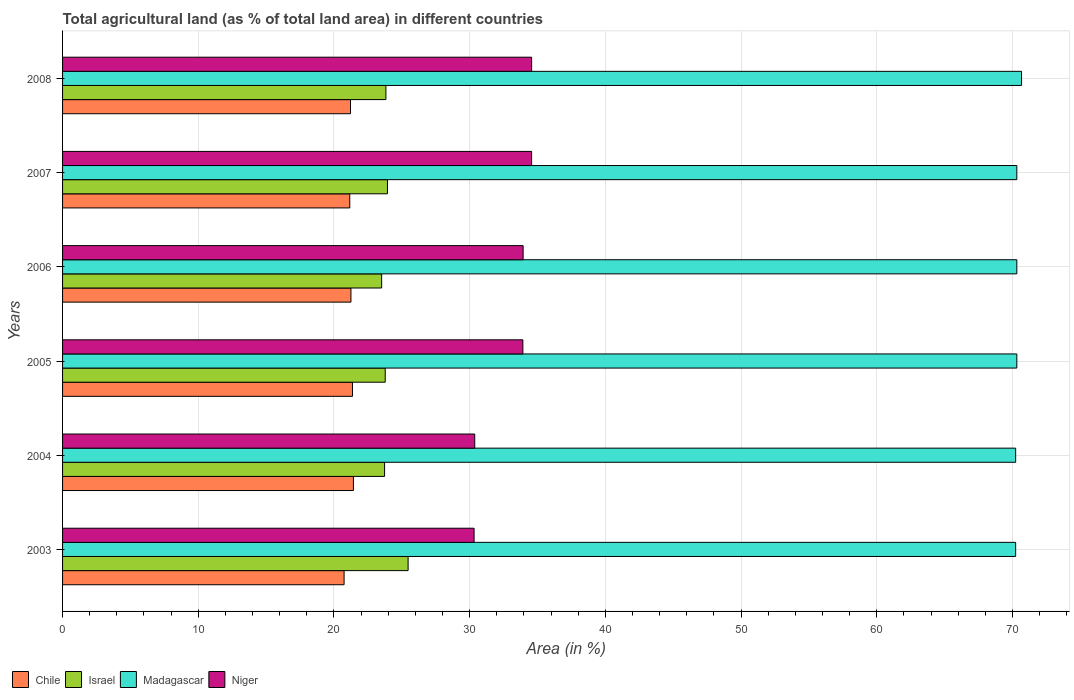How many different coloured bars are there?
Make the answer very short. 4. How many groups of bars are there?
Keep it short and to the point. 6. Are the number of bars per tick equal to the number of legend labels?
Your response must be concise. Yes. How many bars are there on the 6th tick from the bottom?
Give a very brief answer. 4. What is the percentage of agricultural land in Madagascar in 2003?
Keep it short and to the point. 70.23. Across all years, what is the maximum percentage of agricultural land in Niger?
Ensure brevity in your answer.  34.56. Across all years, what is the minimum percentage of agricultural land in Madagascar?
Provide a succinct answer. 70.23. In which year was the percentage of agricultural land in Niger maximum?
Keep it short and to the point. 2007. In which year was the percentage of agricultural land in Niger minimum?
Your response must be concise. 2003. What is the total percentage of agricultural land in Chile in the graph?
Give a very brief answer. 127.17. What is the difference between the percentage of agricultural land in Madagascar in 2003 and that in 2007?
Your response must be concise. -0.09. What is the difference between the percentage of agricultural land in Chile in 2005 and the percentage of agricultural land in Israel in 2007?
Your answer should be very brief. -2.58. What is the average percentage of agricultural land in Israel per year?
Ensure brevity in your answer.  24.04. In the year 2004, what is the difference between the percentage of agricultural land in Chile and percentage of agricultural land in Israel?
Offer a terse response. -2.3. What is the ratio of the percentage of agricultural land in Niger in 2006 to that in 2007?
Make the answer very short. 0.98. Is the percentage of agricultural land in Madagascar in 2005 less than that in 2007?
Make the answer very short. No. What is the difference between the highest and the second highest percentage of agricultural land in Israel?
Make the answer very short. 1.52. What is the difference between the highest and the lowest percentage of agricultural land in Madagascar?
Your response must be concise. 0.43. What does the 2nd bar from the top in 2007 represents?
Your response must be concise. Madagascar. What does the 3rd bar from the bottom in 2004 represents?
Provide a succinct answer. Madagascar. Is it the case that in every year, the sum of the percentage of agricultural land in Chile and percentage of agricultural land in Niger is greater than the percentage of agricultural land in Madagascar?
Your answer should be very brief. No. Are all the bars in the graph horizontal?
Provide a short and direct response. Yes. How many years are there in the graph?
Offer a very short reply. 6. Does the graph contain any zero values?
Your response must be concise. No. How many legend labels are there?
Keep it short and to the point. 4. What is the title of the graph?
Offer a very short reply. Total agricultural land (as % of total land area) in different countries. Does "Suriname" appear as one of the legend labels in the graph?
Ensure brevity in your answer.  No. What is the label or title of the X-axis?
Ensure brevity in your answer.  Area (in %). What is the label or title of the Y-axis?
Offer a terse response. Years. What is the Area (in %) in Chile in 2003?
Your response must be concise. 20.75. What is the Area (in %) of Israel in 2003?
Give a very brief answer. 25.46. What is the Area (in %) of Madagascar in 2003?
Keep it short and to the point. 70.23. What is the Area (in %) of Niger in 2003?
Your answer should be compact. 30.32. What is the Area (in %) in Chile in 2004?
Your answer should be compact. 21.43. What is the Area (in %) of Israel in 2004?
Ensure brevity in your answer.  23.73. What is the Area (in %) of Madagascar in 2004?
Provide a short and direct response. 70.23. What is the Area (in %) of Niger in 2004?
Ensure brevity in your answer.  30.37. What is the Area (in %) of Chile in 2005?
Your answer should be compact. 21.36. What is the Area (in %) in Israel in 2005?
Offer a very short reply. 23.78. What is the Area (in %) in Madagascar in 2005?
Offer a terse response. 70.32. What is the Area (in %) in Niger in 2005?
Keep it short and to the point. 33.92. What is the Area (in %) in Chile in 2006?
Keep it short and to the point. 21.25. What is the Area (in %) of Israel in 2006?
Make the answer very short. 23.51. What is the Area (in %) in Madagascar in 2006?
Your answer should be compact. 70.32. What is the Area (in %) in Niger in 2006?
Make the answer very short. 33.94. What is the Area (in %) of Chile in 2007?
Provide a short and direct response. 21.16. What is the Area (in %) in Israel in 2007?
Give a very brief answer. 23.94. What is the Area (in %) in Madagascar in 2007?
Give a very brief answer. 70.32. What is the Area (in %) of Niger in 2007?
Your response must be concise. 34.56. What is the Area (in %) in Chile in 2008?
Your answer should be very brief. 21.22. What is the Area (in %) of Israel in 2008?
Make the answer very short. 23.83. What is the Area (in %) in Madagascar in 2008?
Give a very brief answer. 70.67. What is the Area (in %) of Niger in 2008?
Your answer should be compact. 34.56. Across all years, what is the maximum Area (in %) in Chile?
Offer a terse response. 21.43. Across all years, what is the maximum Area (in %) of Israel?
Keep it short and to the point. 25.46. Across all years, what is the maximum Area (in %) of Madagascar?
Ensure brevity in your answer.  70.67. Across all years, what is the maximum Area (in %) in Niger?
Your answer should be very brief. 34.56. Across all years, what is the minimum Area (in %) of Chile?
Give a very brief answer. 20.75. Across all years, what is the minimum Area (in %) of Israel?
Provide a succinct answer. 23.51. Across all years, what is the minimum Area (in %) in Madagascar?
Offer a terse response. 70.23. Across all years, what is the minimum Area (in %) in Niger?
Keep it short and to the point. 30.32. What is the total Area (in %) of Chile in the graph?
Provide a succinct answer. 127.17. What is the total Area (in %) in Israel in the graph?
Offer a terse response. 144.25. What is the total Area (in %) of Madagascar in the graph?
Make the answer very short. 422.09. What is the total Area (in %) of Niger in the graph?
Give a very brief answer. 197.68. What is the difference between the Area (in %) of Chile in 2003 and that in 2004?
Your answer should be compact. -0.69. What is the difference between the Area (in %) in Israel in 2003 and that in 2004?
Offer a terse response. 1.73. What is the difference between the Area (in %) of Madagascar in 2003 and that in 2004?
Your answer should be compact. 0. What is the difference between the Area (in %) of Niger in 2003 and that in 2004?
Your answer should be compact. -0.05. What is the difference between the Area (in %) in Chile in 2003 and that in 2005?
Your answer should be very brief. -0.62. What is the difference between the Area (in %) of Israel in 2003 and that in 2005?
Make the answer very short. 1.69. What is the difference between the Area (in %) of Madagascar in 2003 and that in 2005?
Your response must be concise. -0.09. What is the difference between the Area (in %) in Niger in 2003 and that in 2005?
Make the answer very short. -3.59. What is the difference between the Area (in %) of Chile in 2003 and that in 2006?
Offer a terse response. -0.5. What is the difference between the Area (in %) in Israel in 2003 and that in 2006?
Keep it short and to the point. 1.95. What is the difference between the Area (in %) of Madagascar in 2003 and that in 2006?
Provide a succinct answer. -0.09. What is the difference between the Area (in %) of Niger in 2003 and that in 2006?
Provide a short and direct response. -3.61. What is the difference between the Area (in %) in Chile in 2003 and that in 2007?
Your answer should be very brief. -0.42. What is the difference between the Area (in %) of Israel in 2003 and that in 2007?
Offer a terse response. 1.52. What is the difference between the Area (in %) in Madagascar in 2003 and that in 2007?
Give a very brief answer. -0.09. What is the difference between the Area (in %) in Niger in 2003 and that in 2007?
Your answer should be very brief. -4.24. What is the difference between the Area (in %) of Chile in 2003 and that in 2008?
Keep it short and to the point. -0.47. What is the difference between the Area (in %) in Israel in 2003 and that in 2008?
Ensure brevity in your answer.  1.64. What is the difference between the Area (in %) in Madagascar in 2003 and that in 2008?
Your answer should be very brief. -0.43. What is the difference between the Area (in %) of Niger in 2003 and that in 2008?
Give a very brief answer. -4.24. What is the difference between the Area (in %) in Chile in 2004 and that in 2005?
Your answer should be very brief. 0.07. What is the difference between the Area (in %) of Israel in 2004 and that in 2005?
Provide a succinct answer. -0.05. What is the difference between the Area (in %) of Madagascar in 2004 and that in 2005?
Ensure brevity in your answer.  -0.09. What is the difference between the Area (in %) in Niger in 2004 and that in 2005?
Offer a terse response. -3.55. What is the difference between the Area (in %) in Chile in 2004 and that in 2006?
Ensure brevity in your answer.  0.18. What is the difference between the Area (in %) in Israel in 2004 and that in 2006?
Offer a very short reply. 0.22. What is the difference between the Area (in %) in Madagascar in 2004 and that in 2006?
Offer a terse response. -0.09. What is the difference between the Area (in %) in Niger in 2004 and that in 2006?
Make the answer very short. -3.57. What is the difference between the Area (in %) of Chile in 2004 and that in 2007?
Your response must be concise. 0.27. What is the difference between the Area (in %) in Israel in 2004 and that in 2007?
Your answer should be very brief. -0.21. What is the difference between the Area (in %) in Madagascar in 2004 and that in 2007?
Ensure brevity in your answer.  -0.09. What is the difference between the Area (in %) of Niger in 2004 and that in 2007?
Your response must be concise. -4.19. What is the difference between the Area (in %) of Chile in 2004 and that in 2008?
Your answer should be compact. 0.21. What is the difference between the Area (in %) of Israel in 2004 and that in 2008?
Your answer should be very brief. -0.1. What is the difference between the Area (in %) in Madagascar in 2004 and that in 2008?
Keep it short and to the point. -0.43. What is the difference between the Area (in %) of Niger in 2004 and that in 2008?
Make the answer very short. -4.19. What is the difference between the Area (in %) of Chile in 2005 and that in 2006?
Your response must be concise. 0.11. What is the difference between the Area (in %) in Israel in 2005 and that in 2006?
Offer a terse response. 0.26. What is the difference between the Area (in %) in Madagascar in 2005 and that in 2006?
Ensure brevity in your answer.  0. What is the difference between the Area (in %) in Niger in 2005 and that in 2006?
Give a very brief answer. -0.02. What is the difference between the Area (in %) in Chile in 2005 and that in 2007?
Make the answer very short. 0.2. What is the difference between the Area (in %) of Israel in 2005 and that in 2007?
Ensure brevity in your answer.  -0.17. What is the difference between the Area (in %) of Niger in 2005 and that in 2007?
Provide a short and direct response. -0.65. What is the difference between the Area (in %) of Chile in 2005 and that in 2008?
Keep it short and to the point. 0.15. What is the difference between the Area (in %) of Israel in 2005 and that in 2008?
Offer a terse response. -0.05. What is the difference between the Area (in %) of Madagascar in 2005 and that in 2008?
Offer a very short reply. -0.35. What is the difference between the Area (in %) in Niger in 2005 and that in 2008?
Offer a terse response. -0.65. What is the difference between the Area (in %) in Chile in 2006 and that in 2007?
Your answer should be very brief. 0.09. What is the difference between the Area (in %) of Israel in 2006 and that in 2007?
Provide a succinct answer. -0.43. What is the difference between the Area (in %) of Madagascar in 2006 and that in 2007?
Your response must be concise. 0. What is the difference between the Area (in %) in Niger in 2006 and that in 2007?
Give a very brief answer. -0.63. What is the difference between the Area (in %) in Chile in 2006 and that in 2008?
Provide a short and direct response. 0.03. What is the difference between the Area (in %) of Israel in 2006 and that in 2008?
Make the answer very short. -0.31. What is the difference between the Area (in %) of Madagascar in 2006 and that in 2008?
Offer a very short reply. -0.35. What is the difference between the Area (in %) of Niger in 2006 and that in 2008?
Your response must be concise. -0.63. What is the difference between the Area (in %) in Chile in 2007 and that in 2008?
Offer a very short reply. -0.05. What is the difference between the Area (in %) in Israel in 2007 and that in 2008?
Your answer should be compact. 0.12. What is the difference between the Area (in %) of Madagascar in 2007 and that in 2008?
Make the answer very short. -0.35. What is the difference between the Area (in %) in Chile in 2003 and the Area (in %) in Israel in 2004?
Provide a short and direct response. -2.98. What is the difference between the Area (in %) of Chile in 2003 and the Area (in %) of Madagascar in 2004?
Offer a very short reply. -49.49. What is the difference between the Area (in %) in Chile in 2003 and the Area (in %) in Niger in 2004?
Offer a terse response. -9.63. What is the difference between the Area (in %) in Israel in 2003 and the Area (in %) in Madagascar in 2004?
Give a very brief answer. -44.77. What is the difference between the Area (in %) of Israel in 2003 and the Area (in %) of Niger in 2004?
Keep it short and to the point. -4.91. What is the difference between the Area (in %) in Madagascar in 2003 and the Area (in %) in Niger in 2004?
Ensure brevity in your answer.  39.86. What is the difference between the Area (in %) in Chile in 2003 and the Area (in %) in Israel in 2005?
Provide a succinct answer. -3.03. What is the difference between the Area (in %) in Chile in 2003 and the Area (in %) in Madagascar in 2005?
Provide a succinct answer. -49.57. What is the difference between the Area (in %) of Chile in 2003 and the Area (in %) of Niger in 2005?
Ensure brevity in your answer.  -13.17. What is the difference between the Area (in %) in Israel in 2003 and the Area (in %) in Madagascar in 2005?
Give a very brief answer. -44.86. What is the difference between the Area (in %) of Israel in 2003 and the Area (in %) of Niger in 2005?
Make the answer very short. -8.46. What is the difference between the Area (in %) in Madagascar in 2003 and the Area (in %) in Niger in 2005?
Offer a terse response. 36.31. What is the difference between the Area (in %) of Chile in 2003 and the Area (in %) of Israel in 2006?
Make the answer very short. -2.77. What is the difference between the Area (in %) in Chile in 2003 and the Area (in %) in Madagascar in 2006?
Your answer should be very brief. -49.57. What is the difference between the Area (in %) in Chile in 2003 and the Area (in %) in Niger in 2006?
Your answer should be very brief. -13.19. What is the difference between the Area (in %) in Israel in 2003 and the Area (in %) in Madagascar in 2006?
Give a very brief answer. -44.86. What is the difference between the Area (in %) in Israel in 2003 and the Area (in %) in Niger in 2006?
Offer a very short reply. -8.48. What is the difference between the Area (in %) in Madagascar in 2003 and the Area (in %) in Niger in 2006?
Offer a terse response. 36.29. What is the difference between the Area (in %) in Chile in 2003 and the Area (in %) in Israel in 2007?
Provide a succinct answer. -3.2. What is the difference between the Area (in %) in Chile in 2003 and the Area (in %) in Madagascar in 2007?
Keep it short and to the point. -49.57. What is the difference between the Area (in %) of Chile in 2003 and the Area (in %) of Niger in 2007?
Provide a short and direct response. -13.82. What is the difference between the Area (in %) in Israel in 2003 and the Area (in %) in Madagascar in 2007?
Give a very brief answer. -44.86. What is the difference between the Area (in %) in Israel in 2003 and the Area (in %) in Niger in 2007?
Provide a succinct answer. -9.1. What is the difference between the Area (in %) of Madagascar in 2003 and the Area (in %) of Niger in 2007?
Your answer should be compact. 35.67. What is the difference between the Area (in %) in Chile in 2003 and the Area (in %) in Israel in 2008?
Offer a very short reply. -3.08. What is the difference between the Area (in %) in Chile in 2003 and the Area (in %) in Madagascar in 2008?
Offer a terse response. -49.92. What is the difference between the Area (in %) in Chile in 2003 and the Area (in %) in Niger in 2008?
Your response must be concise. -13.82. What is the difference between the Area (in %) in Israel in 2003 and the Area (in %) in Madagascar in 2008?
Offer a terse response. -45.2. What is the difference between the Area (in %) in Israel in 2003 and the Area (in %) in Niger in 2008?
Keep it short and to the point. -9.1. What is the difference between the Area (in %) of Madagascar in 2003 and the Area (in %) of Niger in 2008?
Your answer should be compact. 35.67. What is the difference between the Area (in %) of Chile in 2004 and the Area (in %) of Israel in 2005?
Your answer should be compact. -2.34. What is the difference between the Area (in %) in Chile in 2004 and the Area (in %) in Madagascar in 2005?
Give a very brief answer. -48.89. What is the difference between the Area (in %) in Chile in 2004 and the Area (in %) in Niger in 2005?
Offer a terse response. -12.49. What is the difference between the Area (in %) in Israel in 2004 and the Area (in %) in Madagascar in 2005?
Make the answer very short. -46.59. What is the difference between the Area (in %) of Israel in 2004 and the Area (in %) of Niger in 2005?
Your response must be concise. -10.19. What is the difference between the Area (in %) in Madagascar in 2004 and the Area (in %) in Niger in 2005?
Give a very brief answer. 36.31. What is the difference between the Area (in %) in Chile in 2004 and the Area (in %) in Israel in 2006?
Your answer should be compact. -2.08. What is the difference between the Area (in %) of Chile in 2004 and the Area (in %) of Madagascar in 2006?
Provide a short and direct response. -48.89. What is the difference between the Area (in %) of Chile in 2004 and the Area (in %) of Niger in 2006?
Ensure brevity in your answer.  -12.51. What is the difference between the Area (in %) in Israel in 2004 and the Area (in %) in Madagascar in 2006?
Provide a succinct answer. -46.59. What is the difference between the Area (in %) in Israel in 2004 and the Area (in %) in Niger in 2006?
Make the answer very short. -10.21. What is the difference between the Area (in %) in Madagascar in 2004 and the Area (in %) in Niger in 2006?
Your response must be concise. 36.29. What is the difference between the Area (in %) of Chile in 2004 and the Area (in %) of Israel in 2007?
Provide a succinct answer. -2.51. What is the difference between the Area (in %) of Chile in 2004 and the Area (in %) of Madagascar in 2007?
Your answer should be compact. -48.89. What is the difference between the Area (in %) of Chile in 2004 and the Area (in %) of Niger in 2007?
Provide a succinct answer. -13.13. What is the difference between the Area (in %) in Israel in 2004 and the Area (in %) in Madagascar in 2007?
Offer a very short reply. -46.59. What is the difference between the Area (in %) in Israel in 2004 and the Area (in %) in Niger in 2007?
Your response must be concise. -10.83. What is the difference between the Area (in %) in Madagascar in 2004 and the Area (in %) in Niger in 2007?
Offer a very short reply. 35.67. What is the difference between the Area (in %) of Chile in 2004 and the Area (in %) of Israel in 2008?
Offer a very short reply. -2.39. What is the difference between the Area (in %) of Chile in 2004 and the Area (in %) of Madagascar in 2008?
Ensure brevity in your answer.  -49.23. What is the difference between the Area (in %) in Chile in 2004 and the Area (in %) in Niger in 2008?
Provide a short and direct response. -13.13. What is the difference between the Area (in %) of Israel in 2004 and the Area (in %) of Madagascar in 2008?
Ensure brevity in your answer.  -46.94. What is the difference between the Area (in %) in Israel in 2004 and the Area (in %) in Niger in 2008?
Make the answer very short. -10.83. What is the difference between the Area (in %) in Madagascar in 2004 and the Area (in %) in Niger in 2008?
Keep it short and to the point. 35.67. What is the difference between the Area (in %) in Chile in 2005 and the Area (in %) in Israel in 2006?
Your answer should be compact. -2.15. What is the difference between the Area (in %) in Chile in 2005 and the Area (in %) in Madagascar in 2006?
Provide a succinct answer. -48.95. What is the difference between the Area (in %) of Chile in 2005 and the Area (in %) of Niger in 2006?
Your answer should be very brief. -12.57. What is the difference between the Area (in %) of Israel in 2005 and the Area (in %) of Madagascar in 2006?
Ensure brevity in your answer.  -46.54. What is the difference between the Area (in %) of Israel in 2005 and the Area (in %) of Niger in 2006?
Make the answer very short. -10.16. What is the difference between the Area (in %) of Madagascar in 2005 and the Area (in %) of Niger in 2006?
Provide a short and direct response. 36.38. What is the difference between the Area (in %) in Chile in 2005 and the Area (in %) in Israel in 2007?
Give a very brief answer. -2.58. What is the difference between the Area (in %) in Chile in 2005 and the Area (in %) in Madagascar in 2007?
Provide a short and direct response. -48.95. What is the difference between the Area (in %) in Chile in 2005 and the Area (in %) in Niger in 2007?
Provide a succinct answer. -13.2. What is the difference between the Area (in %) in Israel in 2005 and the Area (in %) in Madagascar in 2007?
Make the answer very short. -46.54. What is the difference between the Area (in %) of Israel in 2005 and the Area (in %) of Niger in 2007?
Provide a succinct answer. -10.79. What is the difference between the Area (in %) in Madagascar in 2005 and the Area (in %) in Niger in 2007?
Your response must be concise. 35.75. What is the difference between the Area (in %) of Chile in 2005 and the Area (in %) of Israel in 2008?
Make the answer very short. -2.46. What is the difference between the Area (in %) in Chile in 2005 and the Area (in %) in Madagascar in 2008?
Offer a very short reply. -49.3. What is the difference between the Area (in %) of Chile in 2005 and the Area (in %) of Niger in 2008?
Provide a succinct answer. -13.2. What is the difference between the Area (in %) of Israel in 2005 and the Area (in %) of Madagascar in 2008?
Provide a short and direct response. -46.89. What is the difference between the Area (in %) in Israel in 2005 and the Area (in %) in Niger in 2008?
Make the answer very short. -10.79. What is the difference between the Area (in %) in Madagascar in 2005 and the Area (in %) in Niger in 2008?
Your response must be concise. 35.75. What is the difference between the Area (in %) of Chile in 2006 and the Area (in %) of Israel in 2007?
Offer a very short reply. -2.69. What is the difference between the Area (in %) in Chile in 2006 and the Area (in %) in Madagascar in 2007?
Your answer should be very brief. -49.07. What is the difference between the Area (in %) in Chile in 2006 and the Area (in %) in Niger in 2007?
Offer a terse response. -13.31. What is the difference between the Area (in %) in Israel in 2006 and the Area (in %) in Madagascar in 2007?
Provide a short and direct response. -46.81. What is the difference between the Area (in %) of Israel in 2006 and the Area (in %) of Niger in 2007?
Ensure brevity in your answer.  -11.05. What is the difference between the Area (in %) in Madagascar in 2006 and the Area (in %) in Niger in 2007?
Your answer should be compact. 35.75. What is the difference between the Area (in %) in Chile in 2006 and the Area (in %) in Israel in 2008?
Give a very brief answer. -2.58. What is the difference between the Area (in %) of Chile in 2006 and the Area (in %) of Madagascar in 2008?
Keep it short and to the point. -49.42. What is the difference between the Area (in %) in Chile in 2006 and the Area (in %) in Niger in 2008?
Ensure brevity in your answer.  -13.31. What is the difference between the Area (in %) in Israel in 2006 and the Area (in %) in Madagascar in 2008?
Your answer should be compact. -47.15. What is the difference between the Area (in %) of Israel in 2006 and the Area (in %) of Niger in 2008?
Your answer should be very brief. -11.05. What is the difference between the Area (in %) of Madagascar in 2006 and the Area (in %) of Niger in 2008?
Provide a succinct answer. 35.75. What is the difference between the Area (in %) in Chile in 2007 and the Area (in %) in Israel in 2008?
Your response must be concise. -2.66. What is the difference between the Area (in %) in Chile in 2007 and the Area (in %) in Madagascar in 2008?
Offer a very short reply. -49.5. What is the difference between the Area (in %) of Chile in 2007 and the Area (in %) of Niger in 2008?
Your answer should be very brief. -13.4. What is the difference between the Area (in %) in Israel in 2007 and the Area (in %) in Madagascar in 2008?
Your answer should be compact. -46.72. What is the difference between the Area (in %) in Israel in 2007 and the Area (in %) in Niger in 2008?
Keep it short and to the point. -10.62. What is the difference between the Area (in %) of Madagascar in 2007 and the Area (in %) of Niger in 2008?
Ensure brevity in your answer.  35.75. What is the average Area (in %) of Chile per year?
Offer a very short reply. 21.2. What is the average Area (in %) in Israel per year?
Give a very brief answer. 24.04. What is the average Area (in %) in Madagascar per year?
Make the answer very short. 70.35. What is the average Area (in %) of Niger per year?
Give a very brief answer. 32.95. In the year 2003, what is the difference between the Area (in %) in Chile and Area (in %) in Israel?
Keep it short and to the point. -4.72. In the year 2003, what is the difference between the Area (in %) in Chile and Area (in %) in Madagascar?
Ensure brevity in your answer.  -49.49. In the year 2003, what is the difference between the Area (in %) of Chile and Area (in %) of Niger?
Keep it short and to the point. -9.58. In the year 2003, what is the difference between the Area (in %) of Israel and Area (in %) of Madagascar?
Offer a terse response. -44.77. In the year 2003, what is the difference between the Area (in %) of Israel and Area (in %) of Niger?
Your response must be concise. -4.86. In the year 2003, what is the difference between the Area (in %) of Madagascar and Area (in %) of Niger?
Your response must be concise. 39.91. In the year 2004, what is the difference between the Area (in %) of Chile and Area (in %) of Israel?
Provide a succinct answer. -2.3. In the year 2004, what is the difference between the Area (in %) in Chile and Area (in %) in Madagascar?
Your answer should be compact. -48.8. In the year 2004, what is the difference between the Area (in %) of Chile and Area (in %) of Niger?
Ensure brevity in your answer.  -8.94. In the year 2004, what is the difference between the Area (in %) of Israel and Area (in %) of Madagascar?
Give a very brief answer. -46.5. In the year 2004, what is the difference between the Area (in %) of Israel and Area (in %) of Niger?
Ensure brevity in your answer.  -6.64. In the year 2004, what is the difference between the Area (in %) in Madagascar and Area (in %) in Niger?
Make the answer very short. 39.86. In the year 2005, what is the difference between the Area (in %) of Chile and Area (in %) of Israel?
Provide a succinct answer. -2.41. In the year 2005, what is the difference between the Area (in %) of Chile and Area (in %) of Madagascar?
Your response must be concise. -48.95. In the year 2005, what is the difference between the Area (in %) in Chile and Area (in %) in Niger?
Keep it short and to the point. -12.55. In the year 2005, what is the difference between the Area (in %) of Israel and Area (in %) of Madagascar?
Give a very brief answer. -46.54. In the year 2005, what is the difference between the Area (in %) in Israel and Area (in %) in Niger?
Keep it short and to the point. -10.14. In the year 2005, what is the difference between the Area (in %) in Madagascar and Area (in %) in Niger?
Offer a very short reply. 36.4. In the year 2006, what is the difference between the Area (in %) of Chile and Area (in %) of Israel?
Provide a succinct answer. -2.26. In the year 2006, what is the difference between the Area (in %) in Chile and Area (in %) in Madagascar?
Provide a short and direct response. -49.07. In the year 2006, what is the difference between the Area (in %) in Chile and Area (in %) in Niger?
Your answer should be compact. -12.69. In the year 2006, what is the difference between the Area (in %) of Israel and Area (in %) of Madagascar?
Offer a very short reply. -46.81. In the year 2006, what is the difference between the Area (in %) in Israel and Area (in %) in Niger?
Your answer should be very brief. -10.43. In the year 2006, what is the difference between the Area (in %) in Madagascar and Area (in %) in Niger?
Keep it short and to the point. 36.38. In the year 2007, what is the difference between the Area (in %) of Chile and Area (in %) of Israel?
Your answer should be compact. -2.78. In the year 2007, what is the difference between the Area (in %) in Chile and Area (in %) in Madagascar?
Your answer should be very brief. -49.15. In the year 2007, what is the difference between the Area (in %) in Chile and Area (in %) in Niger?
Your answer should be very brief. -13.4. In the year 2007, what is the difference between the Area (in %) of Israel and Area (in %) of Madagascar?
Keep it short and to the point. -46.38. In the year 2007, what is the difference between the Area (in %) of Israel and Area (in %) of Niger?
Offer a terse response. -10.62. In the year 2007, what is the difference between the Area (in %) of Madagascar and Area (in %) of Niger?
Ensure brevity in your answer.  35.75. In the year 2008, what is the difference between the Area (in %) in Chile and Area (in %) in Israel?
Keep it short and to the point. -2.61. In the year 2008, what is the difference between the Area (in %) in Chile and Area (in %) in Madagascar?
Offer a terse response. -49.45. In the year 2008, what is the difference between the Area (in %) of Chile and Area (in %) of Niger?
Provide a succinct answer. -13.35. In the year 2008, what is the difference between the Area (in %) in Israel and Area (in %) in Madagascar?
Provide a succinct answer. -46.84. In the year 2008, what is the difference between the Area (in %) of Israel and Area (in %) of Niger?
Ensure brevity in your answer.  -10.74. In the year 2008, what is the difference between the Area (in %) of Madagascar and Area (in %) of Niger?
Offer a terse response. 36.1. What is the ratio of the Area (in %) in Chile in 2003 to that in 2004?
Provide a short and direct response. 0.97. What is the ratio of the Area (in %) of Israel in 2003 to that in 2004?
Keep it short and to the point. 1.07. What is the ratio of the Area (in %) of Niger in 2003 to that in 2004?
Ensure brevity in your answer.  1. What is the ratio of the Area (in %) of Israel in 2003 to that in 2005?
Keep it short and to the point. 1.07. What is the ratio of the Area (in %) in Niger in 2003 to that in 2005?
Keep it short and to the point. 0.89. What is the ratio of the Area (in %) in Chile in 2003 to that in 2006?
Give a very brief answer. 0.98. What is the ratio of the Area (in %) of Israel in 2003 to that in 2006?
Your answer should be compact. 1.08. What is the ratio of the Area (in %) in Madagascar in 2003 to that in 2006?
Offer a very short reply. 1. What is the ratio of the Area (in %) in Niger in 2003 to that in 2006?
Provide a short and direct response. 0.89. What is the ratio of the Area (in %) in Chile in 2003 to that in 2007?
Offer a terse response. 0.98. What is the ratio of the Area (in %) in Israel in 2003 to that in 2007?
Make the answer very short. 1.06. What is the ratio of the Area (in %) in Madagascar in 2003 to that in 2007?
Give a very brief answer. 1. What is the ratio of the Area (in %) of Niger in 2003 to that in 2007?
Give a very brief answer. 0.88. What is the ratio of the Area (in %) in Chile in 2003 to that in 2008?
Ensure brevity in your answer.  0.98. What is the ratio of the Area (in %) in Israel in 2003 to that in 2008?
Make the answer very short. 1.07. What is the ratio of the Area (in %) in Madagascar in 2003 to that in 2008?
Make the answer very short. 0.99. What is the ratio of the Area (in %) of Niger in 2003 to that in 2008?
Your response must be concise. 0.88. What is the ratio of the Area (in %) of Chile in 2004 to that in 2005?
Make the answer very short. 1. What is the ratio of the Area (in %) of Israel in 2004 to that in 2005?
Give a very brief answer. 1. What is the ratio of the Area (in %) of Madagascar in 2004 to that in 2005?
Your answer should be very brief. 1. What is the ratio of the Area (in %) of Niger in 2004 to that in 2005?
Your answer should be compact. 0.9. What is the ratio of the Area (in %) in Chile in 2004 to that in 2006?
Your response must be concise. 1.01. What is the ratio of the Area (in %) in Israel in 2004 to that in 2006?
Your answer should be compact. 1.01. What is the ratio of the Area (in %) of Niger in 2004 to that in 2006?
Your answer should be compact. 0.89. What is the ratio of the Area (in %) of Chile in 2004 to that in 2007?
Your answer should be compact. 1.01. What is the ratio of the Area (in %) of Israel in 2004 to that in 2007?
Offer a very short reply. 0.99. What is the ratio of the Area (in %) in Niger in 2004 to that in 2007?
Offer a very short reply. 0.88. What is the ratio of the Area (in %) in Niger in 2004 to that in 2008?
Provide a short and direct response. 0.88. What is the ratio of the Area (in %) of Chile in 2005 to that in 2006?
Your answer should be compact. 1.01. What is the ratio of the Area (in %) of Israel in 2005 to that in 2006?
Your answer should be compact. 1.01. What is the ratio of the Area (in %) of Madagascar in 2005 to that in 2006?
Provide a succinct answer. 1. What is the ratio of the Area (in %) in Niger in 2005 to that in 2006?
Provide a succinct answer. 1. What is the ratio of the Area (in %) of Chile in 2005 to that in 2007?
Provide a succinct answer. 1.01. What is the ratio of the Area (in %) of Madagascar in 2005 to that in 2007?
Provide a succinct answer. 1. What is the ratio of the Area (in %) of Niger in 2005 to that in 2007?
Your answer should be very brief. 0.98. What is the ratio of the Area (in %) of Madagascar in 2005 to that in 2008?
Make the answer very short. 1. What is the ratio of the Area (in %) in Niger in 2005 to that in 2008?
Provide a short and direct response. 0.98. What is the ratio of the Area (in %) of Chile in 2006 to that in 2007?
Offer a terse response. 1. What is the ratio of the Area (in %) of Israel in 2006 to that in 2007?
Your response must be concise. 0.98. What is the ratio of the Area (in %) in Madagascar in 2006 to that in 2007?
Provide a succinct answer. 1. What is the ratio of the Area (in %) in Niger in 2006 to that in 2007?
Offer a terse response. 0.98. What is the ratio of the Area (in %) of Madagascar in 2006 to that in 2008?
Offer a terse response. 1. What is the ratio of the Area (in %) in Niger in 2006 to that in 2008?
Provide a short and direct response. 0.98. What is the ratio of the Area (in %) of Israel in 2007 to that in 2008?
Make the answer very short. 1. What is the ratio of the Area (in %) of Madagascar in 2007 to that in 2008?
Your answer should be very brief. 1. What is the ratio of the Area (in %) of Niger in 2007 to that in 2008?
Provide a short and direct response. 1. What is the difference between the highest and the second highest Area (in %) of Chile?
Your answer should be compact. 0.07. What is the difference between the highest and the second highest Area (in %) of Israel?
Your answer should be compact. 1.52. What is the difference between the highest and the second highest Area (in %) of Madagascar?
Make the answer very short. 0.35. What is the difference between the highest and the second highest Area (in %) in Niger?
Offer a terse response. 0. What is the difference between the highest and the lowest Area (in %) of Chile?
Ensure brevity in your answer.  0.69. What is the difference between the highest and the lowest Area (in %) in Israel?
Provide a short and direct response. 1.95. What is the difference between the highest and the lowest Area (in %) of Madagascar?
Ensure brevity in your answer.  0.43. What is the difference between the highest and the lowest Area (in %) of Niger?
Offer a very short reply. 4.24. 